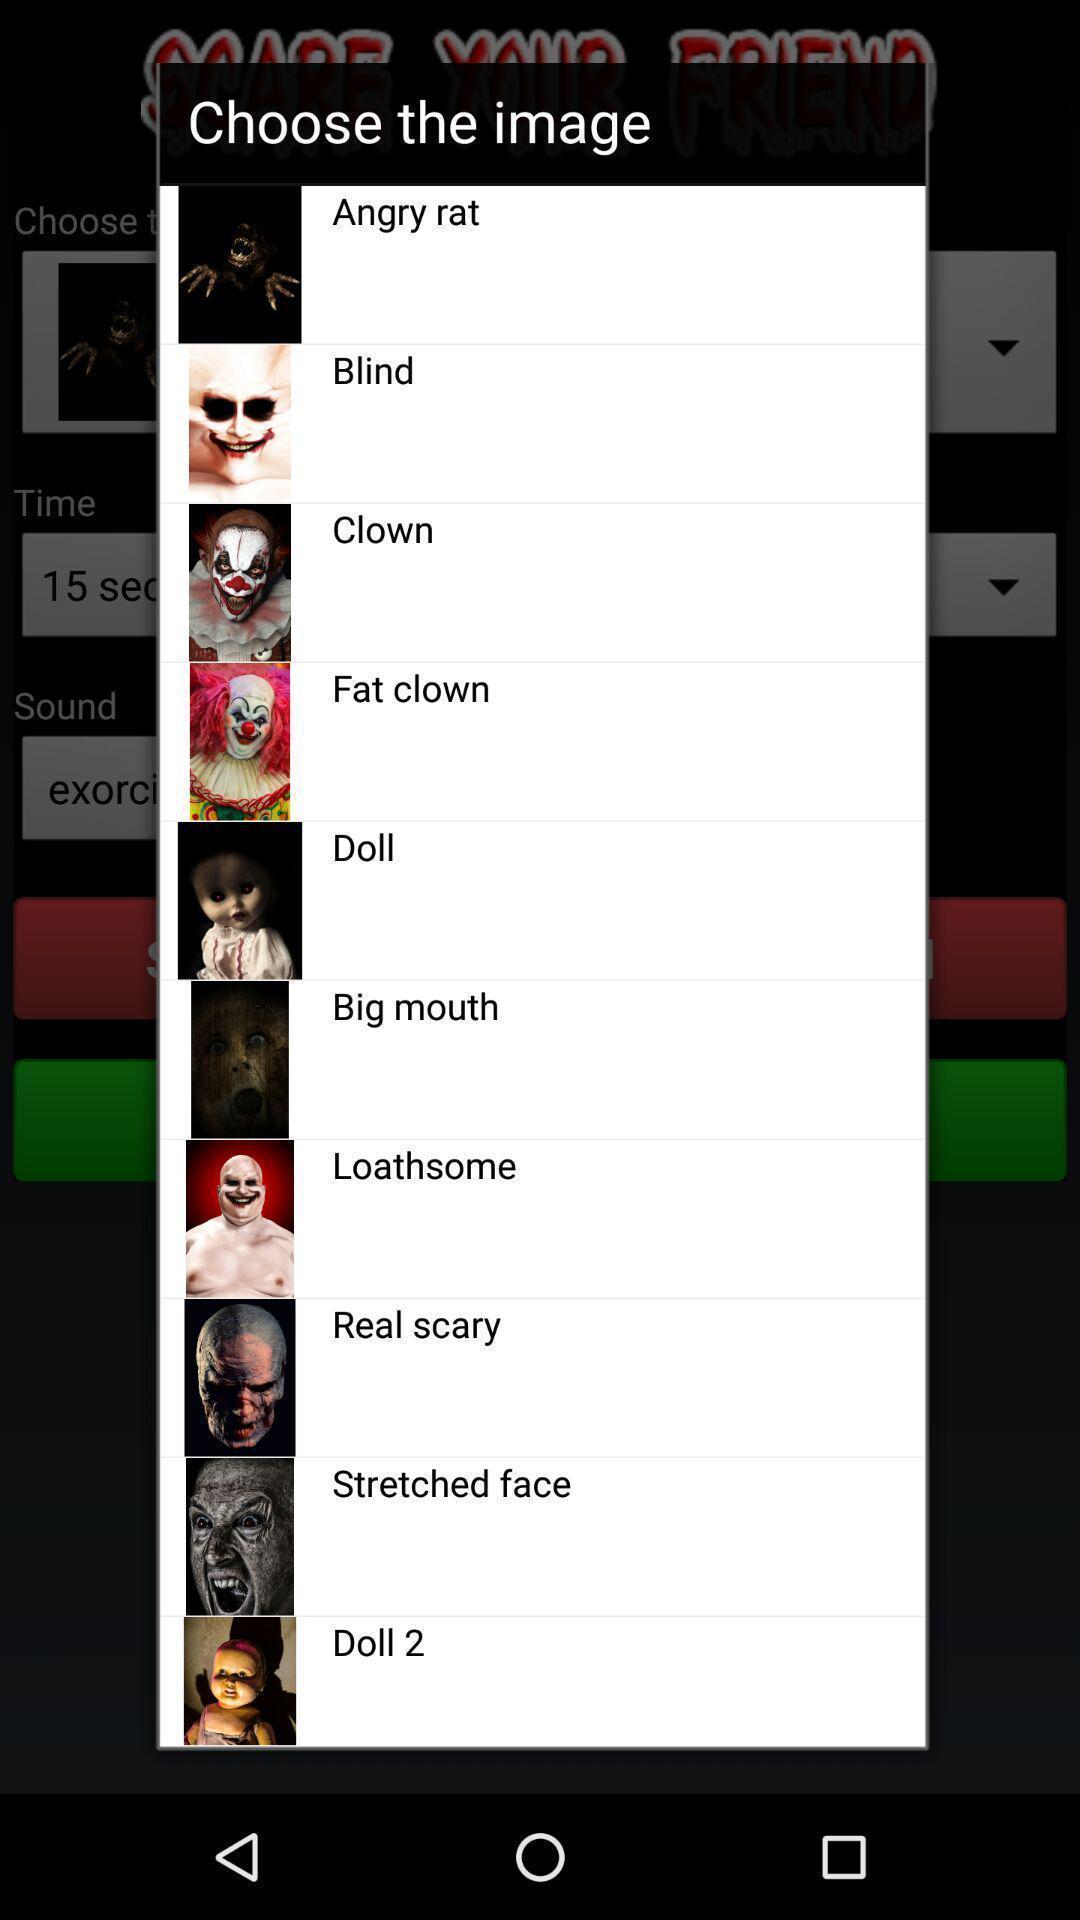Describe the key features of this screenshot. Popup displaying list of images. 